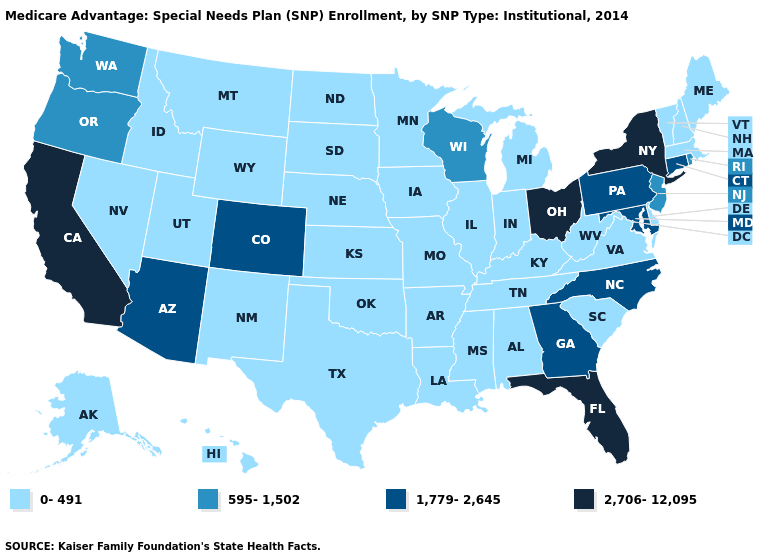What is the highest value in the West ?
Short answer required. 2,706-12,095. Name the states that have a value in the range 2,706-12,095?
Write a very short answer. California, Florida, New York, Ohio. What is the lowest value in the Northeast?
Quick response, please. 0-491. Does Utah have the same value as Arizona?
Short answer required. No. Does Minnesota have the highest value in the USA?
Quick response, please. No. Does the first symbol in the legend represent the smallest category?
Quick response, please. Yes. Name the states that have a value in the range 0-491?
Answer briefly. Alaska, Alabama, Arkansas, Delaware, Hawaii, Iowa, Idaho, Illinois, Indiana, Kansas, Kentucky, Louisiana, Massachusetts, Maine, Michigan, Minnesota, Missouri, Mississippi, Montana, North Dakota, Nebraska, New Hampshire, New Mexico, Nevada, Oklahoma, South Carolina, South Dakota, Tennessee, Texas, Utah, Virginia, Vermont, West Virginia, Wyoming. Does the map have missing data?
Answer briefly. No. Does New Hampshire have the lowest value in the USA?
Write a very short answer. Yes. What is the highest value in states that border Vermont?
Concise answer only. 2,706-12,095. Name the states that have a value in the range 2,706-12,095?
Write a very short answer. California, Florida, New York, Ohio. Does Missouri have the highest value in the MidWest?
Be succinct. No. Name the states that have a value in the range 1,779-2,645?
Short answer required. Arizona, Colorado, Connecticut, Georgia, Maryland, North Carolina, Pennsylvania. Name the states that have a value in the range 0-491?
Give a very brief answer. Alaska, Alabama, Arkansas, Delaware, Hawaii, Iowa, Idaho, Illinois, Indiana, Kansas, Kentucky, Louisiana, Massachusetts, Maine, Michigan, Minnesota, Missouri, Mississippi, Montana, North Dakota, Nebraska, New Hampshire, New Mexico, Nevada, Oklahoma, South Carolina, South Dakota, Tennessee, Texas, Utah, Virginia, Vermont, West Virginia, Wyoming. Name the states that have a value in the range 595-1,502?
Answer briefly. New Jersey, Oregon, Rhode Island, Washington, Wisconsin. 